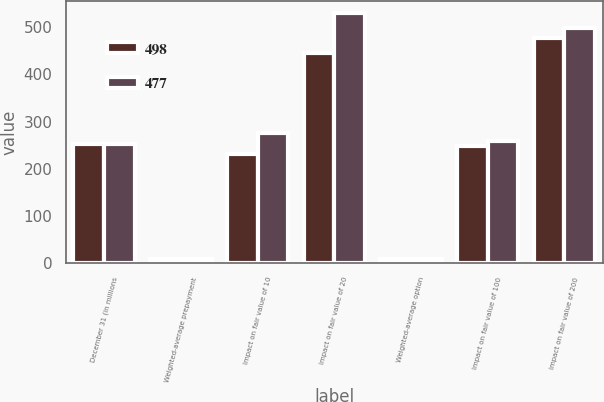Convert chart to OTSL. <chart><loc_0><loc_0><loc_500><loc_500><stacked_bar_chart><ecel><fcel>December 31 (in millions<fcel>Weighted-average prepayment<fcel>Impact on fair value of 10<fcel>Impact on fair value of 20<fcel>Weighted-average option<fcel>Impact on fair value of 100<fcel>Impact on fair value of 200<nl><fcel>498<fcel>253<fcel>9.41<fcel>231<fcel>445<fcel>8.55<fcel>248<fcel>477<nl><fcel>477<fcel>253<fcel>9.81<fcel>275<fcel>529<fcel>9.54<fcel>258<fcel>498<nl></chart> 